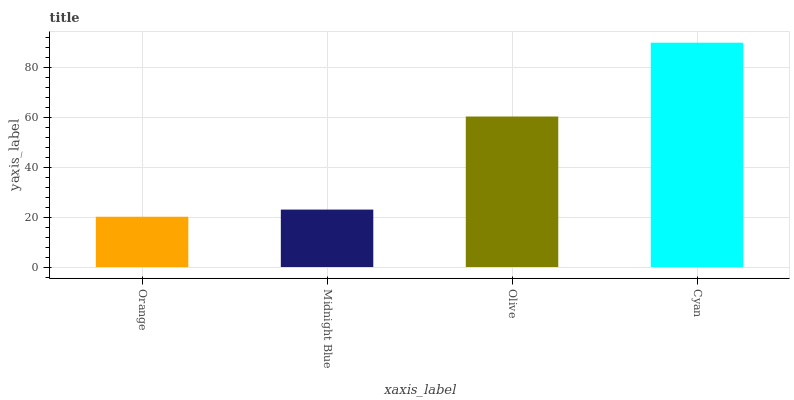Is Midnight Blue the minimum?
Answer yes or no. No. Is Midnight Blue the maximum?
Answer yes or no. No. Is Midnight Blue greater than Orange?
Answer yes or no. Yes. Is Orange less than Midnight Blue?
Answer yes or no. Yes. Is Orange greater than Midnight Blue?
Answer yes or no. No. Is Midnight Blue less than Orange?
Answer yes or no. No. Is Olive the high median?
Answer yes or no. Yes. Is Midnight Blue the low median?
Answer yes or no. Yes. Is Midnight Blue the high median?
Answer yes or no. No. Is Orange the low median?
Answer yes or no. No. 